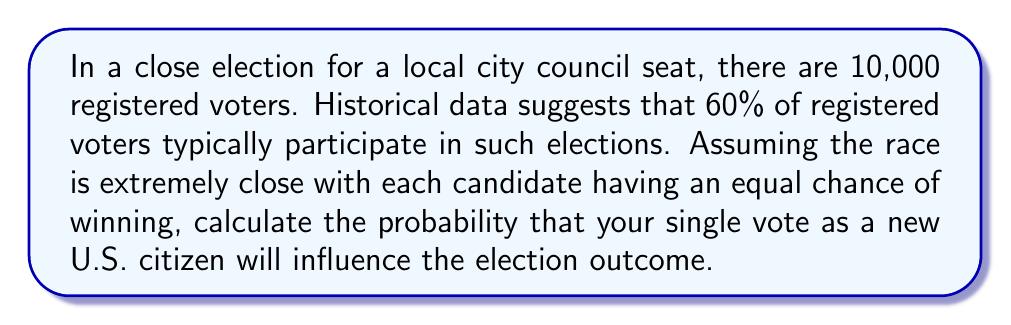Teach me how to tackle this problem. Let's approach this step-by-step:

1) First, we need to calculate the expected number of voters:
   $$ \text{Expected voters} = 10,000 \times 0.60 = 6,000 $$

2) For a single vote to be influential, the election must be tied without that vote. This means we need an even number of voters, with half voting for each candidate.

3) The probability of an exact tie is highest when there's an even number of voters. So, we'll consider the case of 6,000 voters (rounding our expected value).

4) For a tie, we need exactly 3,000 votes for each candidate. This follows a binomial distribution.

5) The probability of this exact split is given by:

   $$ P(\text{tie}) = \binom{6000}{3000} \left(\frac{1}{2}\right)^{6000} $$

6) Using Stirling's approximation for large factorials:

   $$ P(\text{tie}) \approx \frac{1}{\sqrt{\pi n}} \text{ where } n = 3000 $$

7) Calculating:

   $$ P(\text{tie}) \approx \frac{1}{\sqrt{\pi \times 3000}} \approx 0.0103 $$

8) This is the probability that your vote will break a tie, which is equivalent to your vote being influential.

9) Converting to a percentage:

   $$ 0.0103 \times 100\% \approx 1.03\% $$
Answer: $1.03\%$ 